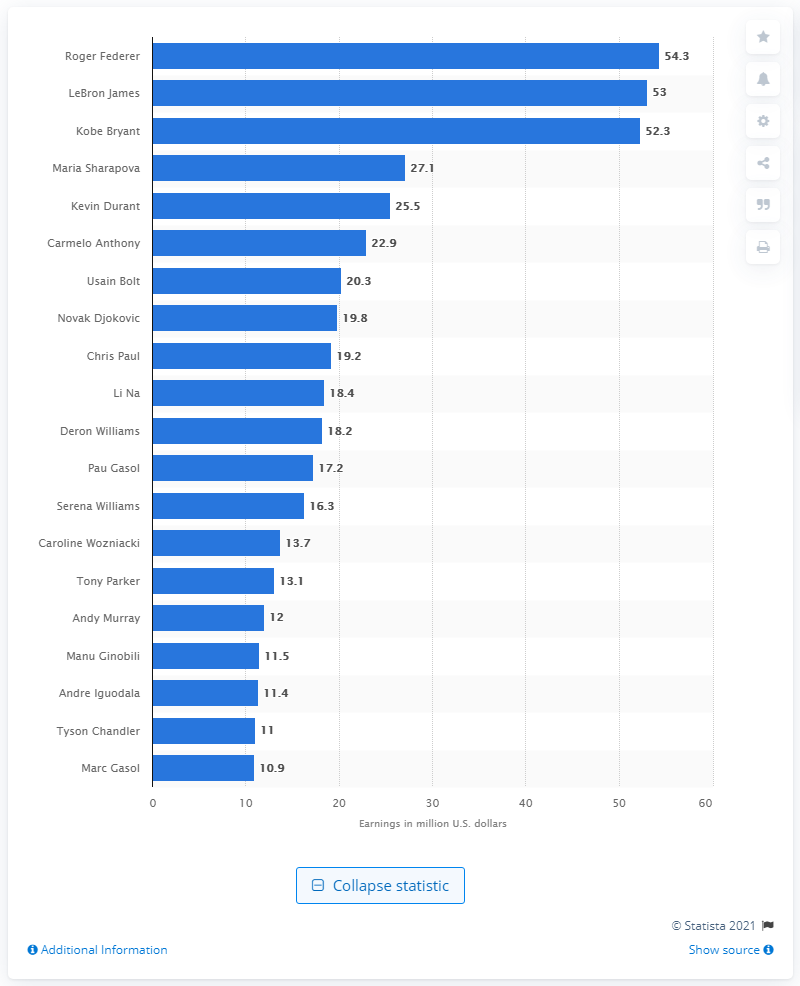Specify some key components in this picture. Roger Federer earned a total of $54,300,000 between July 2011 and July 2012. The individual who was awarded the title of the best-paid Olympic athlete in 2012 was Roger Federer. 